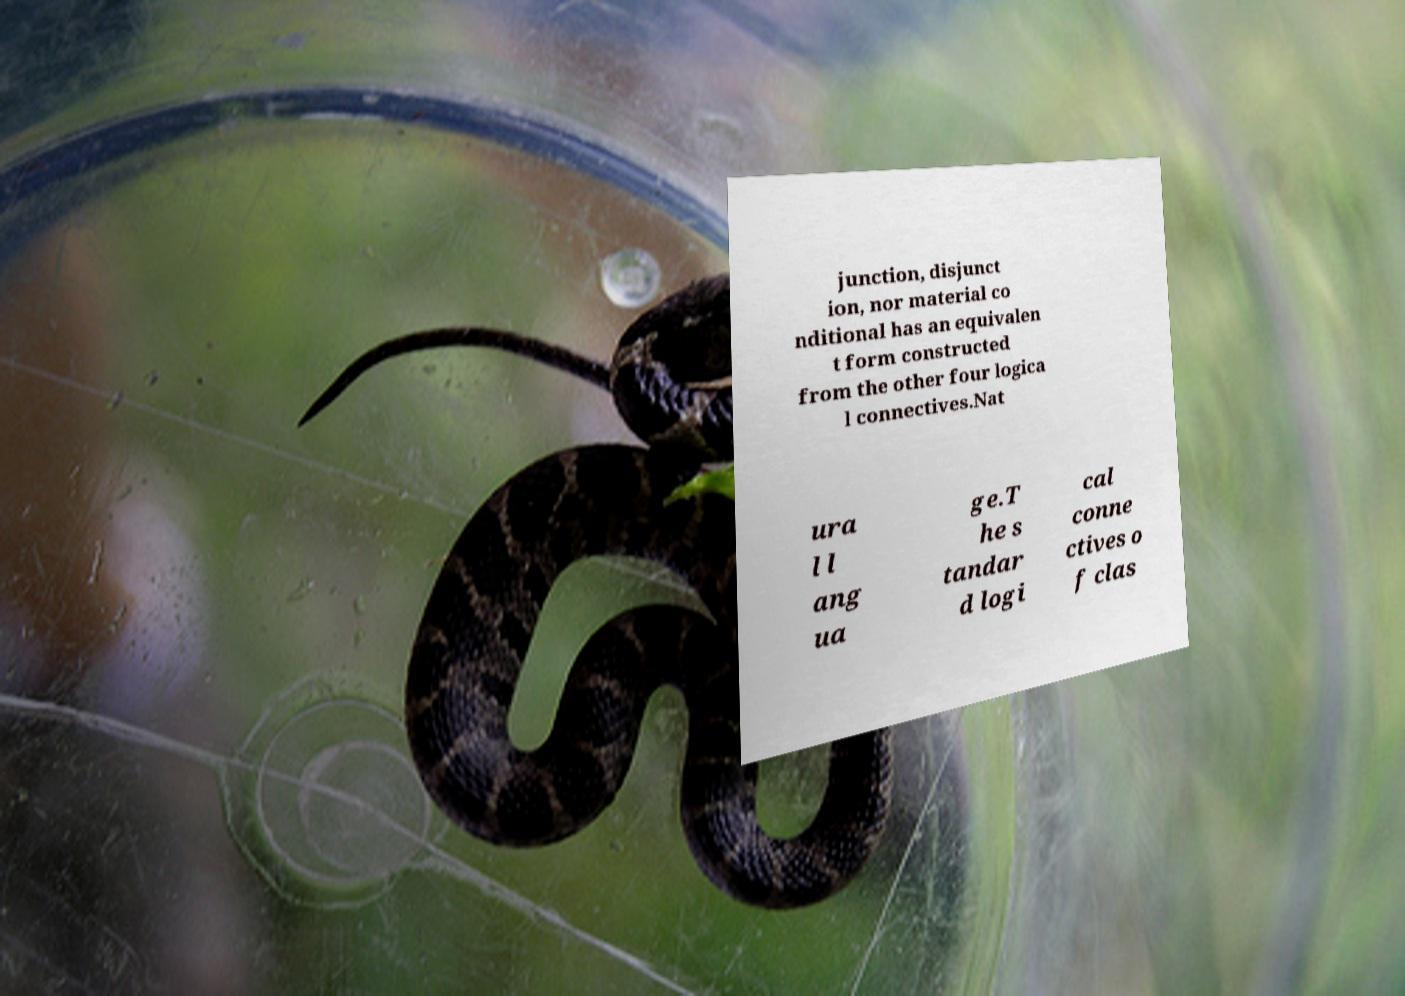There's text embedded in this image that I need extracted. Can you transcribe it verbatim? junction, disjunct ion, nor material co nditional has an equivalen t form constructed from the other four logica l connectives.Nat ura l l ang ua ge.T he s tandar d logi cal conne ctives o f clas 